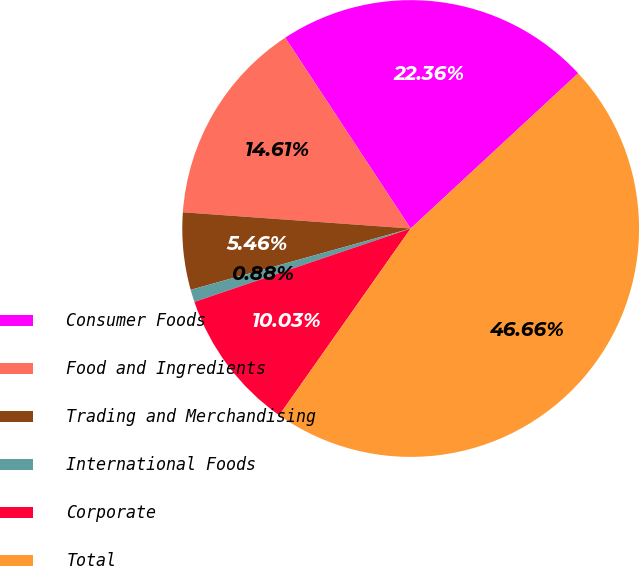Convert chart to OTSL. <chart><loc_0><loc_0><loc_500><loc_500><pie_chart><fcel>Consumer Foods<fcel>Food and Ingredients<fcel>Trading and Merchandising<fcel>International Foods<fcel>Corporate<fcel>Total<nl><fcel>22.36%<fcel>14.61%<fcel>5.46%<fcel>0.88%<fcel>10.03%<fcel>46.66%<nl></chart> 